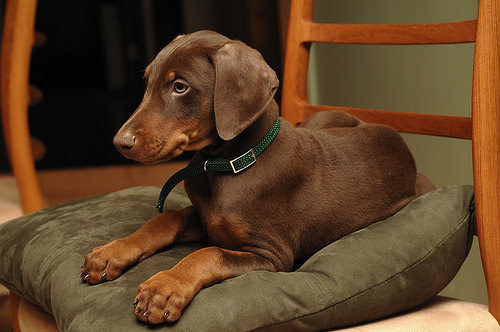<image>
Can you confirm if the dog is on the pillow? Yes. Looking at the image, I can see the dog is positioned on top of the pillow, with the pillow providing support. 